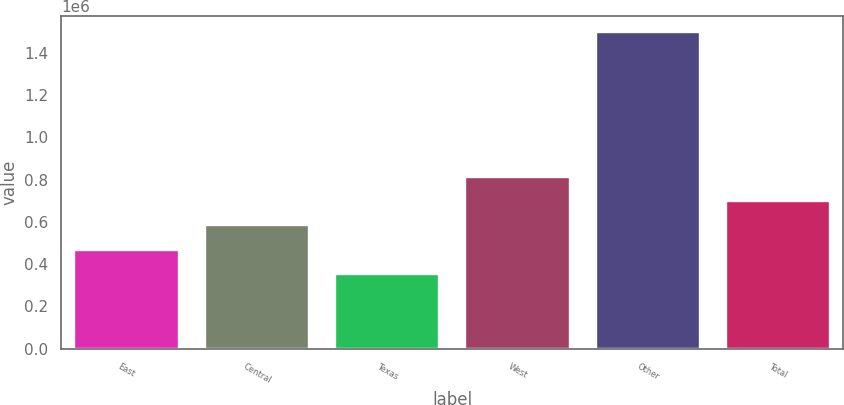Convert chart. <chart><loc_0><loc_0><loc_500><loc_500><bar_chart><fcel>East<fcel>Central<fcel>Texas<fcel>West<fcel>Other<fcel>Total<nl><fcel>468400<fcel>582800<fcel>354000<fcel>811600<fcel>1.498e+06<fcel>697200<nl></chart> 